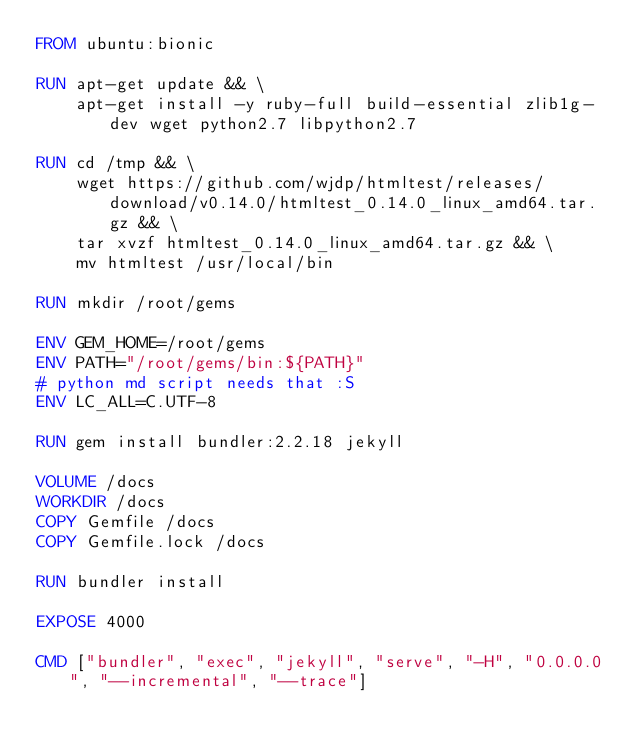Convert code to text. <code><loc_0><loc_0><loc_500><loc_500><_Dockerfile_>FROM ubuntu:bionic

RUN apt-get update && \
    apt-get install -y ruby-full build-essential zlib1g-dev wget python2.7 libpython2.7

RUN cd /tmp && \
    wget https://github.com/wjdp/htmltest/releases/download/v0.14.0/htmltest_0.14.0_linux_amd64.tar.gz && \
    tar xvzf htmltest_0.14.0_linux_amd64.tar.gz && \
    mv htmltest /usr/local/bin

RUN mkdir /root/gems

ENV GEM_HOME=/root/gems
ENV PATH="/root/gems/bin:${PATH}"
# python md script needs that :S
ENV LC_ALL=C.UTF-8

RUN gem install bundler:2.2.18 jekyll

VOLUME /docs
WORKDIR /docs
COPY Gemfile /docs
COPY Gemfile.lock /docs

RUN bundler install

EXPOSE 4000

CMD ["bundler", "exec", "jekyll", "serve", "-H", "0.0.0.0", "--incremental", "--trace"]
</code> 